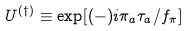<formula> <loc_0><loc_0><loc_500><loc_500>U ^ { ( \dagger ) } \equiv \exp [ ( - ) i \pi _ { a } \tau _ { a } / f _ { \pi } ]</formula> 